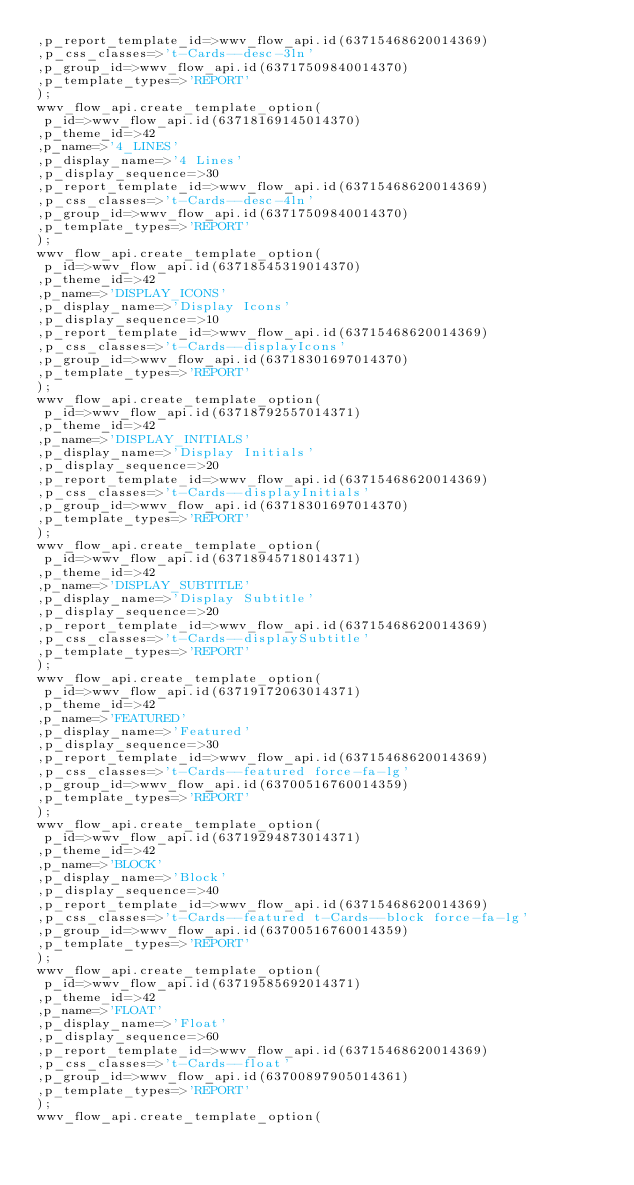Convert code to text. <code><loc_0><loc_0><loc_500><loc_500><_SQL_>,p_report_template_id=>wwv_flow_api.id(63715468620014369)
,p_css_classes=>'t-Cards--desc-3ln'
,p_group_id=>wwv_flow_api.id(63717509840014370)
,p_template_types=>'REPORT'
);
wwv_flow_api.create_template_option(
 p_id=>wwv_flow_api.id(63718169145014370)
,p_theme_id=>42
,p_name=>'4_LINES'
,p_display_name=>'4 Lines'
,p_display_sequence=>30
,p_report_template_id=>wwv_flow_api.id(63715468620014369)
,p_css_classes=>'t-Cards--desc-4ln'
,p_group_id=>wwv_flow_api.id(63717509840014370)
,p_template_types=>'REPORT'
);
wwv_flow_api.create_template_option(
 p_id=>wwv_flow_api.id(63718545319014370)
,p_theme_id=>42
,p_name=>'DISPLAY_ICONS'
,p_display_name=>'Display Icons'
,p_display_sequence=>10
,p_report_template_id=>wwv_flow_api.id(63715468620014369)
,p_css_classes=>'t-Cards--displayIcons'
,p_group_id=>wwv_flow_api.id(63718301697014370)
,p_template_types=>'REPORT'
);
wwv_flow_api.create_template_option(
 p_id=>wwv_flow_api.id(63718792557014371)
,p_theme_id=>42
,p_name=>'DISPLAY_INITIALS'
,p_display_name=>'Display Initials'
,p_display_sequence=>20
,p_report_template_id=>wwv_flow_api.id(63715468620014369)
,p_css_classes=>'t-Cards--displayInitials'
,p_group_id=>wwv_flow_api.id(63718301697014370)
,p_template_types=>'REPORT'
);
wwv_flow_api.create_template_option(
 p_id=>wwv_flow_api.id(63718945718014371)
,p_theme_id=>42
,p_name=>'DISPLAY_SUBTITLE'
,p_display_name=>'Display Subtitle'
,p_display_sequence=>20
,p_report_template_id=>wwv_flow_api.id(63715468620014369)
,p_css_classes=>'t-Cards--displaySubtitle'
,p_template_types=>'REPORT'
);
wwv_flow_api.create_template_option(
 p_id=>wwv_flow_api.id(63719172063014371)
,p_theme_id=>42
,p_name=>'FEATURED'
,p_display_name=>'Featured'
,p_display_sequence=>30
,p_report_template_id=>wwv_flow_api.id(63715468620014369)
,p_css_classes=>'t-Cards--featured force-fa-lg'
,p_group_id=>wwv_flow_api.id(63700516760014359)
,p_template_types=>'REPORT'
);
wwv_flow_api.create_template_option(
 p_id=>wwv_flow_api.id(63719294873014371)
,p_theme_id=>42
,p_name=>'BLOCK'
,p_display_name=>'Block'
,p_display_sequence=>40
,p_report_template_id=>wwv_flow_api.id(63715468620014369)
,p_css_classes=>'t-Cards--featured t-Cards--block force-fa-lg'
,p_group_id=>wwv_flow_api.id(63700516760014359)
,p_template_types=>'REPORT'
);
wwv_flow_api.create_template_option(
 p_id=>wwv_flow_api.id(63719585692014371)
,p_theme_id=>42
,p_name=>'FLOAT'
,p_display_name=>'Float'
,p_display_sequence=>60
,p_report_template_id=>wwv_flow_api.id(63715468620014369)
,p_css_classes=>'t-Cards--float'
,p_group_id=>wwv_flow_api.id(63700897905014361)
,p_template_types=>'REPORT'
);
wwv_flow_api.create_template_option(</code> 